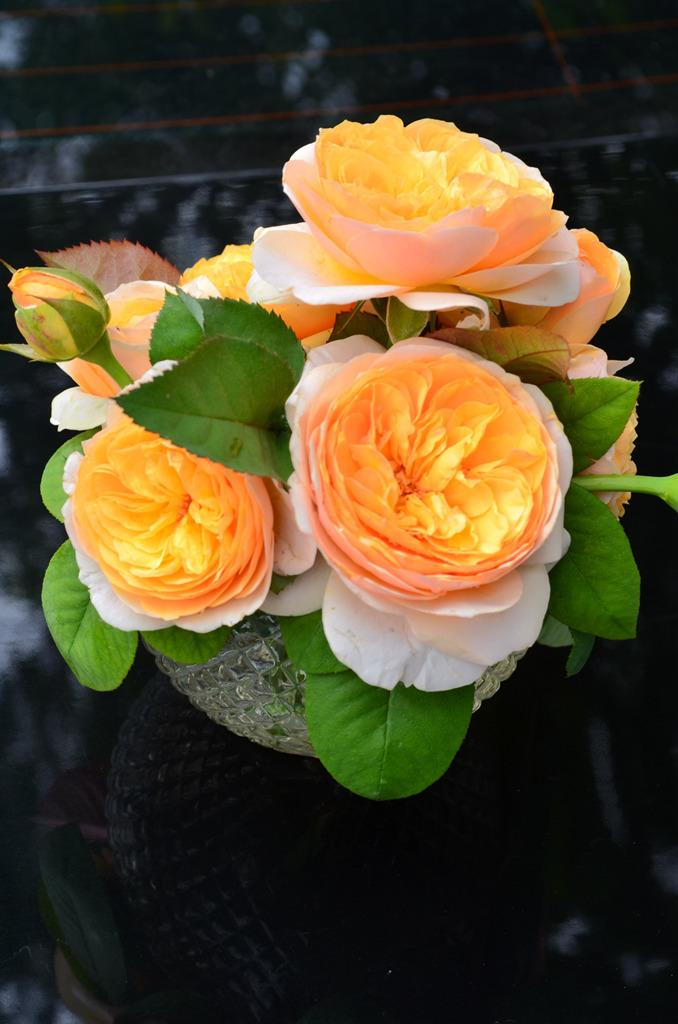What object can be seen in the image? There is a flower vase in the image. What type of vest is being worn by the tomatoes in the image? There are no tomatoes or vests present in the image; it only features a flower vase. 